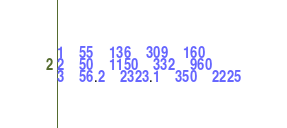<code> <loc_0><loc_0><loc_500><loc_500><_SQL_>1	55	136	309	160
2	50	1150	332	960
3	56.2	2323.1	350	2225
</code> 